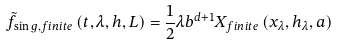Convert formula to latex. <formula><loc_0><loc_0><loc_500><loc_500>\tilde { f } _ { \sin g , f i n i t e } \left ( t , \lambda , h , L \right ) = \frac { 1 } { 2 } \lambda b ^ { d + 1 } X _ { f i n i t e } \left ( x _ { \lambda } , h _ { \lambda } , a \right )</formula> 